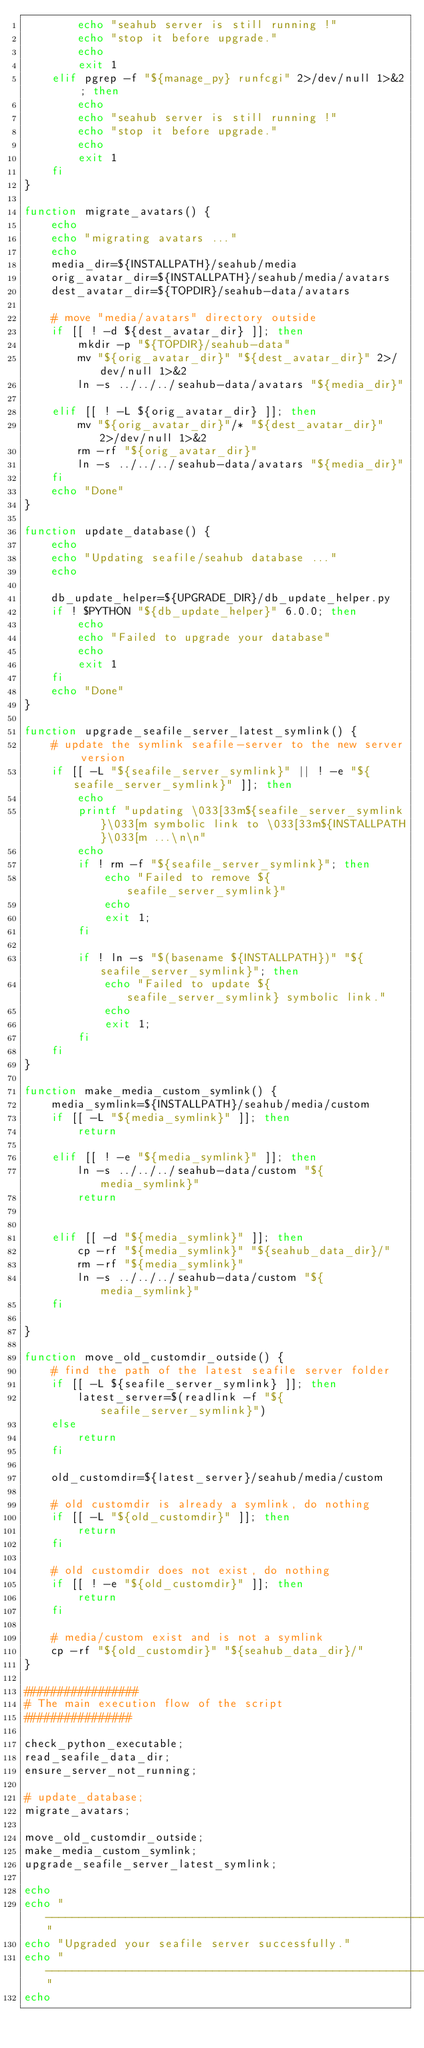<code> <loc_0><loc_0><loc_500><loc_500><_Bash_>        echo "seahub server is still running !"
        echo "stop it before upgrade."
        echo
        exit 1
    elif pgrep -f "${manage_py} runfcgi" 2>/dev/null 1>&2 ; then
        echo
        echo "seahub server is still running !"
        echo "stop it before upgrade."
        echo
        exit 1
    fi
}

function migrate_avatars() {
    echo
    echo "migrating avatars ..."
    echo
    media_dir=${INSTALLPATH}/seahub/media
    orig_avatar_dir=${INSTALLPATH}/seahub/media/avatars
    dest_avatar_dir=${TOPDIR}/seahub-data/avatars

    # move "media/avatars" directory outside
    if [[ ! -d ${dest_avatar_dir} ]]; then
        mkdir -p "${TOPDIR}/seahub-data"
        mv "${orig_avatar_dir}" "${dest_avatar_dir}" 2>/dev/null 1>&2
        ln -s ../../../seahub-data/avatars "${media_dir}"

    elif [[ ! -L ${orig_avatar_dir} ]]; then
        mv "${orig_avatar_dir}"/* "${dest_avatar_dir}" 2>/dev/null 1>&2
        rm -rf "${orig_avatar_dir}"
        ln -s ../../../seahub-data/avatars "${media_dir}"
    fi
    echo "Done"
}

function update_database() {
    echo
    echo "Updating seafile/seahub database ..."
    echo

    db_update_helper=${UPGRADE_DIR}/db_update_helper.py
    if ! $PYTHON "${db_update_helper}" 6.0.0; then
        echo
        echo "Failed to upgrade your database"
        echo
        exit 1
    fi
    echo "Done"
}

function upgrade_seafile_server_latest_symlink() {
    # update the symlink seafile-server to the new server version
    if [[ -L "${seafile_server_symlink}" || ! -e "${seafile_server_symlink}" ]]; then
        echo
        printf "updating \033[33m${seafile_server_symlink}\033[m symbolic link to \033[33m${INSTALLPATH}\033[m ...\n\n"
        echo
        if ! rm -f "${seafile_server_symlink}"; then
            echo "Failed to remove ${seafile_server_symlink}"
            echo
            exit 1;
        fi

        if ! ln -s "$(basename ${INSTALLPATH})" "${seafile_server_symlink}"; then
            echo "Failed to update ${seafile_server_symlink} symbolic link."
            echo
            exit 1;
        fi
    fi
}

function make_media_custom_symlink() {
    media_symlink=${INSTALLPATH}/seahub/media/custom
    if [[ -L "${media_symlink}" ]]; then
        return

    elif [[ ! -e "${media_symlink}" ]]; then
        ln -s ../../../seahub-data/custom "${media_symlink}"
        return


    elif [[ -d "${media_symlink}" ]]; then
        cp -rf "${media_symlink}" "${seahub_data_dir}/"
        rm -rf "${media_symlink}"
        ln -s ../../../seahub-data/custom "${media_symlink}"
    fi

}

function move_old_customdir_outside() {
    # find the path of the latest seafile server folder
    if [[ -L ${seafile_server_symlink} ]]; then
        latest_server=$(readlink -f "${seafile_server_symlink}")
    else
        return
    fi

    old_customdir=${latest_server}/seahub/media/custom

    # old customdir is already a symlink, do nothing
    if [[ -L "${old_customdir}" ]]; then
        return
    fi

    # old customdir does not exist, do nothing
    if [[ ! -e "${old_customdir}" ]]; then
        return
    fi

    # media/custom exist and is not a symlink
    cp -rf "${old_customdir}" "${seahub_data_dir}/"
}

#################
# The main execution flow of the script
################

check_python_executable;
read_seafile_data_dir;
ensure_server_not_running;

# update_database;
migrate_avatars;

move_old_customdir_outside;
make_media_custom_symlink;
upgrade_seafile_server_latest_symlink;

echo
echo "-----------------------------------------------------------------"
echo "Upgraded your seafile server successfully."
echo "-----------------------------------------------------------------"
echo
</code> 